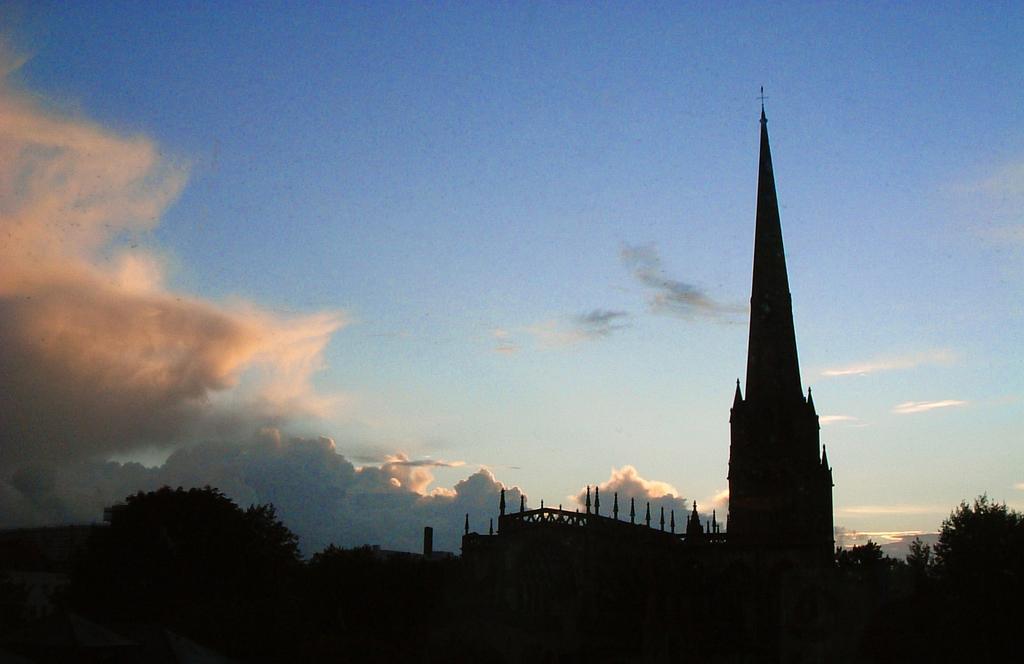Describe this image in one or two sentences. In this image, on the right side, we can see some trees, church, we can also see some poles and a building. On the left side, we can also see some trees. At the top, we can see a sky, at the bottom, we can see black color. 